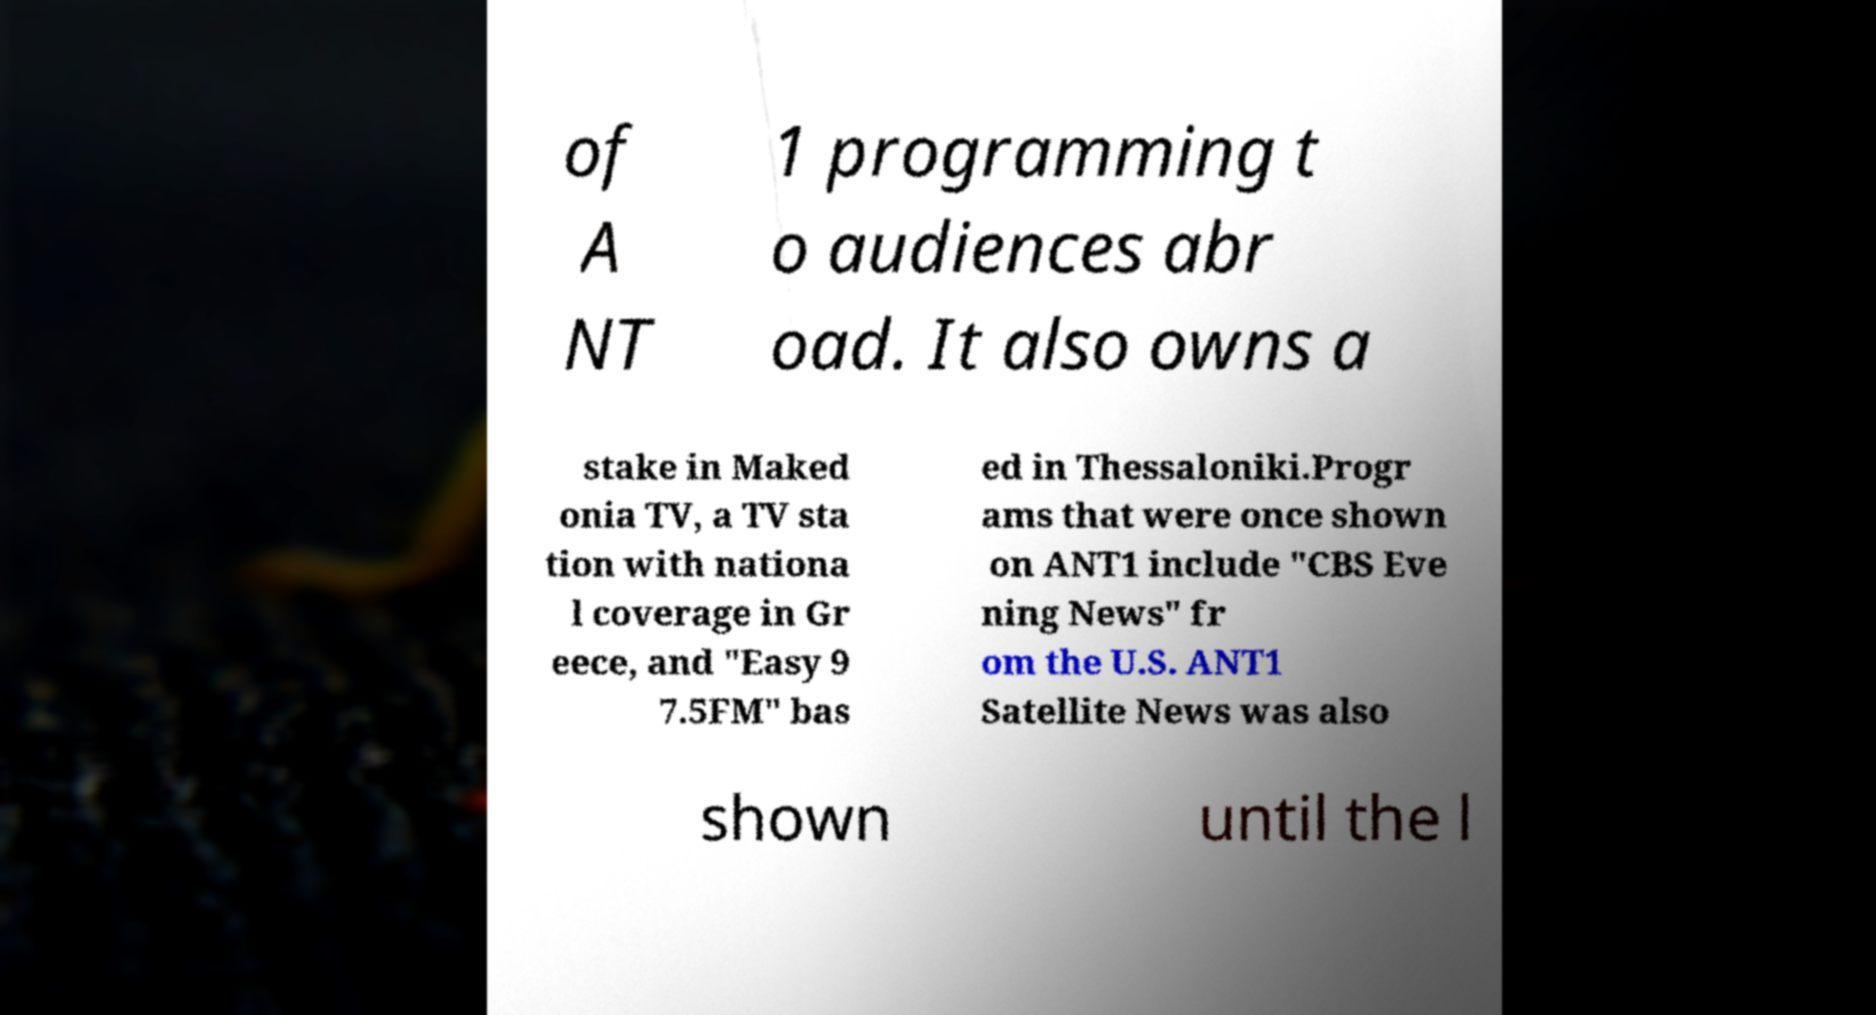For documentation purposes, I need the text within this image transcribed. Could you provide that? of A NT 1 programming t o audiences abr oad. It also owns a stake in Maked onia TV, a TV sta tion with nationa l coverage in Gr eece, and "Easy 9 7.5FM" bas ed in Thessaloniki.Progr ams that were once shown on ANT1 include "CBS Eve ning News" fr om the U.S. ANT1 Satellite News was also shown until the l 